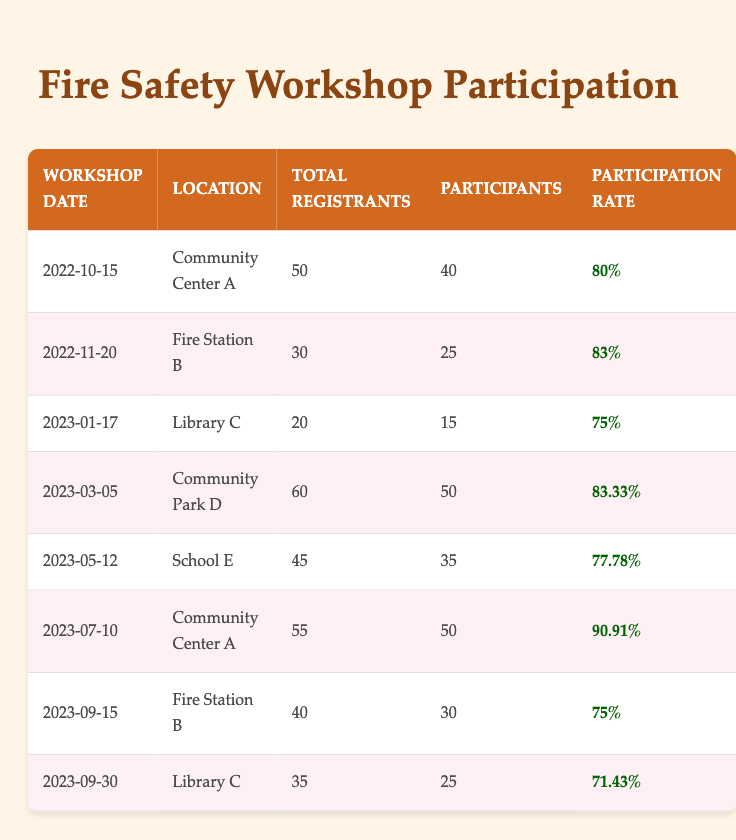What was the highest participation rate in the workshops? Looking through the table, the participation rates are listed for each workshop. The highest value is found in the workshop held on 2023-07-10 at Community Center A, which shows a participation rate of 90.91%.
Answer: 90.91% How many participants attended the workshop on 2023-03-05? Referring to the specified date of the workshop on the table, it shows that 50 participants attended the workshop on 2023-03-05 at Community Park D.
Answer: 50 What is the average participation rate of all workshops? Summing the participation rates: 80% + 83% + 75% + 83.33% + 77.78% + 90.91% + 75% + 71.43% gives a total of 681.45%. There are 8 workshops, so the average rate is 681.45% / 8 = 85.18%.
Answer: 85.18% Did the participation rate increase from the workshop on 2022-11-20 to the workshop on 2023-05-12? The participation rate on 2022-11-20 was 83%, while on 2023-05-12 it was 77.78%. Since 77.78% is less than 83%, the participation rate did not increase.
Answer: No What was the total number of registrants across all workshops? By adding the total registrants from all workshops: 50 + 30 + 20 + 60 + 45 + 55 + 40 + 35 results in 335 total registrants for all workshops.
Answer: 335 Which workshop had the lowest participation rate, and what was that rate? Scanning the participation rates in the table shows that the lowest participation rate is 71.43%, which occurred during the workshop on 2023-09-30 at Library C.
Answer: 71.43% How many more participants attended the workshop on 2023-07-10 compared to the workshop on 2023-09-30? The workshop on 2023-07-10 had 50 participants, while the one on 2023-09-30 had 25 participants. The difference is 50 - 25 = 25 more participants attended the former.
Answer: 25 Was there a workshop held at Fire Station B with a participation rate of over 80%? Checking the workshops held at Fire Station B, the one on 2022-11-20 had a participation rate of 83%, which is over 80%.
Answer: Yes What is the total number of participants from all workshops at Community Center A? There were two workshops at Community Center A: on 2022-10-15 with 40 participants and on 2023-07-10 with 50 participants. Adding these gives 40 + 50 = 90 participants.
Answer: 90 Which month had the workshop with the most registrants, and how many were registered? Looking at all workshops in the table, the workshop in March 2023 had the most registrants with a total of 60.
Answer: March 2023, 60 registrants 